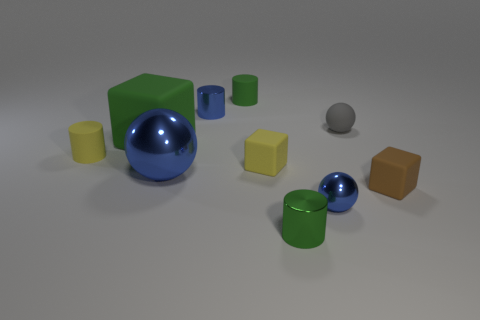Subtract all metal balls. How many balls are left? 1 Subtract all yellow blocks. How many blocks are left? 2 Subtract all balls. How many objects are left? 7 Subtract all cyan balls. How many cyan blocks are left? 0 Subtract all big purple shiny spheres. Subtract all cubes. How many objects are left? 7 Add 1 rubber things. How many rubber things are left? 7 Add 7 tiny green rubber objects. How many tiny green rubber objects exist? 8 Subtract 0 cyan blocks. How many objects are left? 10 Subtract all gray cylinders. Subtract all cyan cubes. How many cylinders are left? 4 